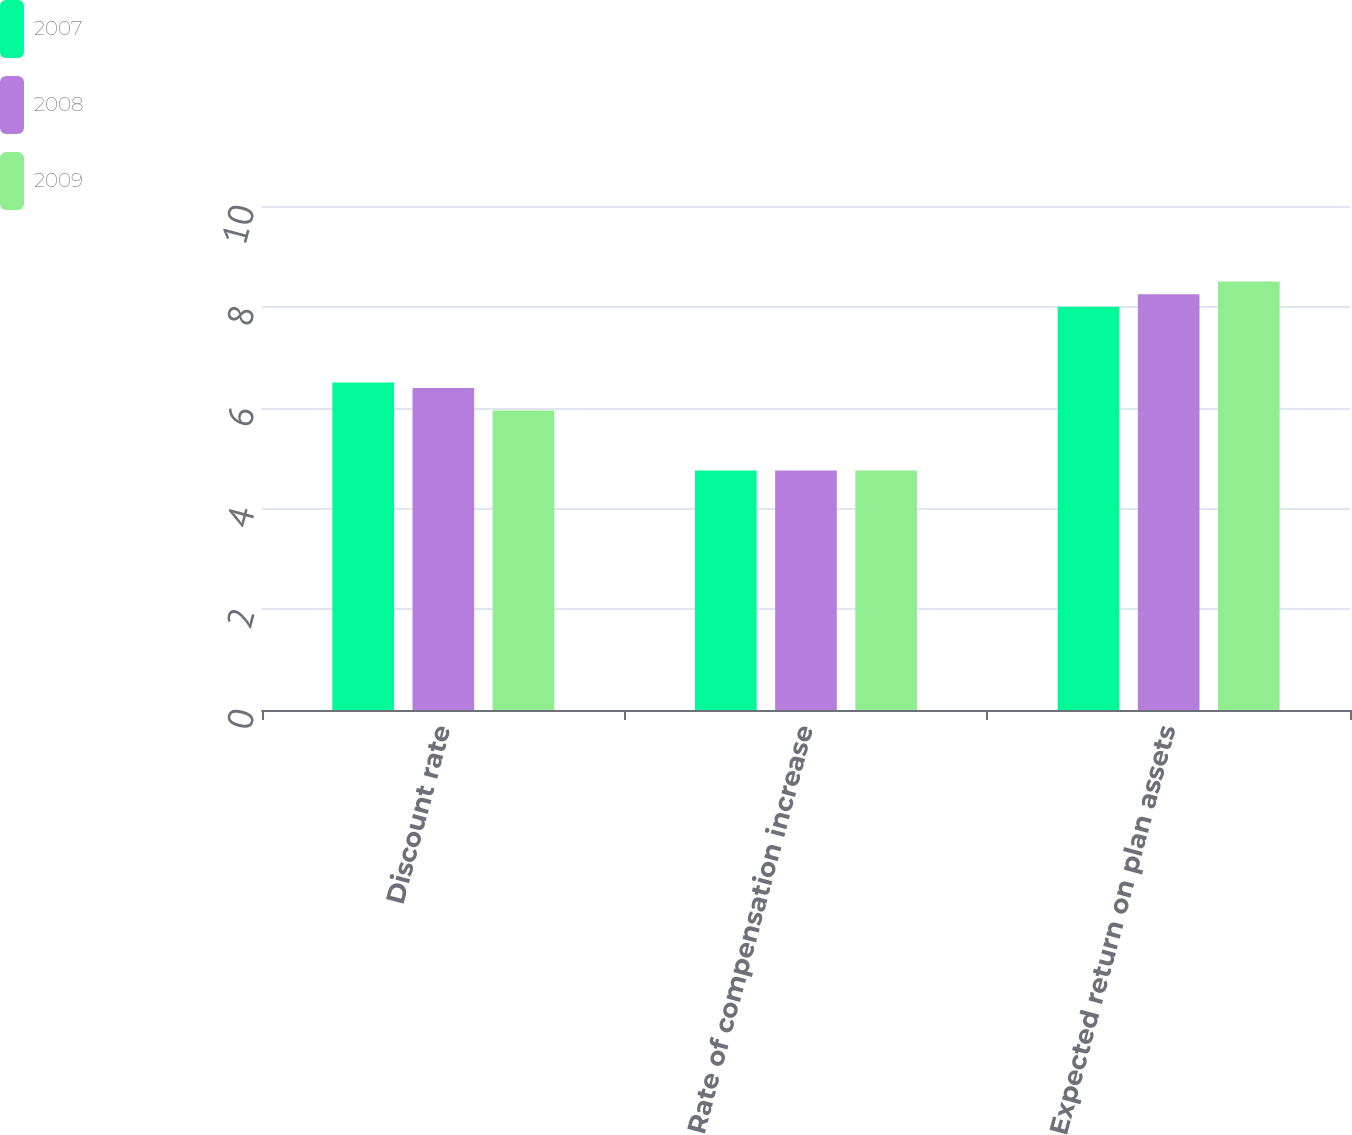Convert chart to OTSL. <chart><loc_0><loc_0><loc_500><loc_500><stacked_bar_chart><ecel><fcel>Discount rate<fcel>Rate of compensation increase<fcel>Expected return on plan assets<nl><fcel>2007<fcel>6.5<fcel>4.75<fcel>8<nl><fcel>2008<fcel>6.39<fcel>4.75<fcel>8.25<nl><fcel>2009<fcel>5.94<fcel>4.75<fcel>8.5<nl></chart> 